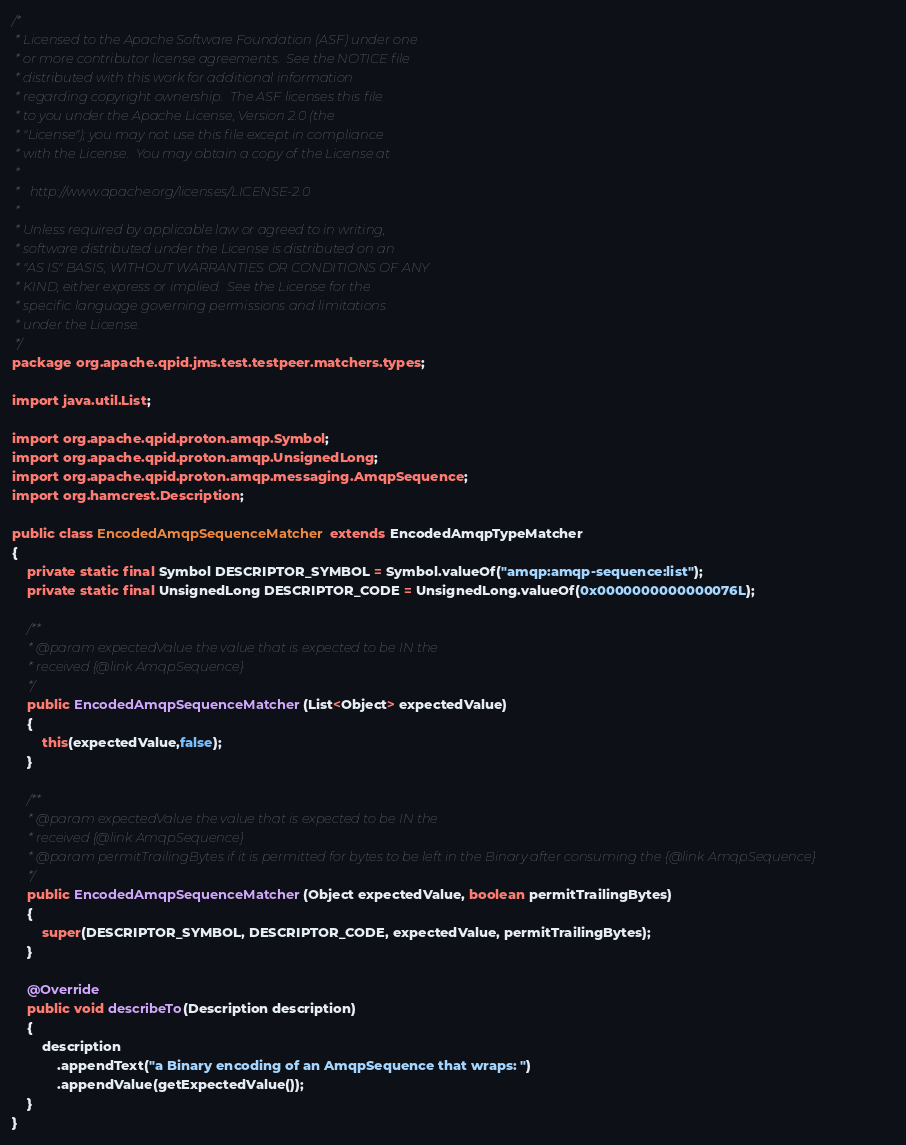Convert code to text. <code><loc_0><loc_0><loc_500><loc_500><_Java_>/*
 * Licensed to the Apache Software Foundation (ASF) under one
 * or more contributor license agreements.  See the NOTICE file
 * distributed with this work for additional information
 * regarding copyright ownership.  The ASF licenses this file
 * to you under the Apache License, Version 2.0 (the
 * "License"); you may not use this file except in compliance
 * with the License.  You may obtain a copy of the License at
 *
 *   http://www.apache.org/licenses/LICENSE-2.0
 *
 * Unless required by applicable law or agreed to in writing,
 * software distributed under the License is distributed on an
 * "AS IS" BASIS, WITHOUT WARRANTIES OR CONDITIONS OF ANY
 * KIND, either express or implied.  See the License for the
 * specific language governing permissions and limitations
 * under the License.
 */
package org.apache.qpid.jms.test.testpeer.matchers.types;

import java.util.List;

import org.apache.qpid.proton.amqp.Symbol;
import org.apache.qpid.proton.amqp.UnsignedLong;
import org.apache.qpid.proton.amqp.messaging.AmqpSequence;
import org.hamcrest.Description;

public class EncodedAmqpSequenceMatcher extends EncodedAmqpTypeMatcher
{
    private static final Symbol DESCRIPTOR_SYMBOL = Symbol.valueOf("amqp:amqp-sequence:list");
    private static final UnsignedLong DESCRIPTOR_CODE = UnsignedLong.valueOf(0x0000000000000076L);

    /**
     * @param expectedValue the value that is expected to be IN the
     * received {@link AmqpSequence}
     */
    public EncodedAmqpSequenceMatcher(List<Object> expectedValue)
    {
        this(expectedValue,false);
    }

    /**
     * @param expectedValue the value that is expected to be IN the
     * received {@link AmqpSequence}
     * @param permitTrailingBytes if it is permitted for bytes to be left in the Binary after consuming the {@link AmqpSequence}
     */
    public EncodedAmqpSequenceMatcher(Object expectedValue, boolean permitTrailingBytes)
    {
        super(DESCRIPTOR_SYMBOL, DESCRIPTOR_CODE, expectedValue, permitTrailingBytes);
    }

    @Override
    public void describeTo(Description description)
    {
        description
            .appendText("a Binary encoding of an AmqpSequence that wraps: ")
            .appendValue(getExpectedValue());
    }
}</code> 